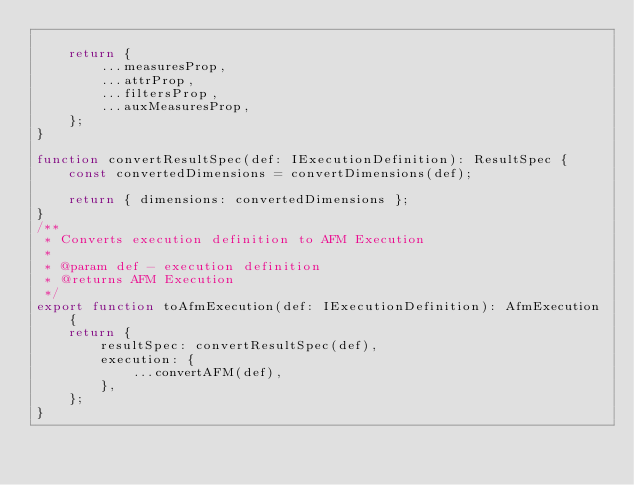<code> <loc_0><loc_0><loc_500><loc_500><_TypeScript_>
    return {
        ...measuresProp,
        ...attrProp,
        ...filtersProp,
        ...auxMeasuresProp,
    };
}

function convertResultSpec(def: IExecutionDefinition): ResultSpec {
    const convertedDimensions = convertDimensions(def);

    return { dimensions: convertedDimensions };
}
/**
 * Converts execution definition to AFM Execution
 *
 * @param def - execution definition
 * @returns AFM Execution
 */
export function toAfmExecution(def: IExecutionDefinition): AfmExecution {
    return {
        resultSpec: convertResultSpec(def),
        execution: {
            ...convertAFM(def),
        },
    };
}
</code> 